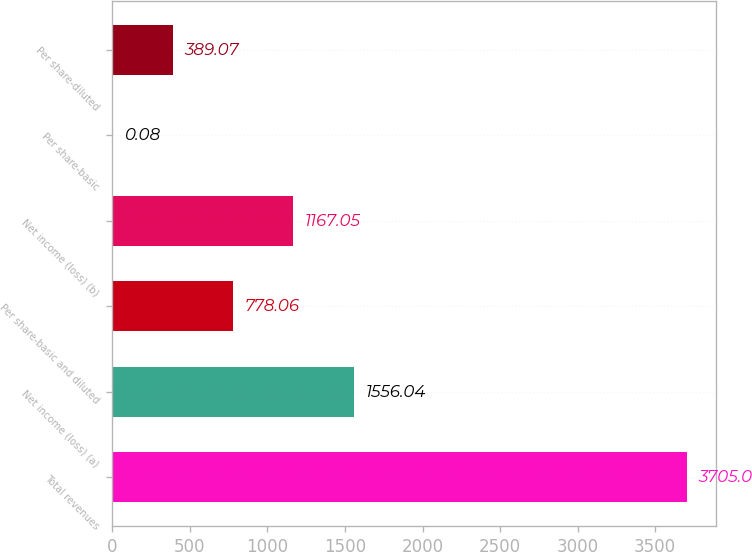Convert chart. <chart><loc_0><loc_0><loc_500><loc_500><bar_chart><fcel>Total revenues<fcel>Net income (loss) (a)<fcel>Per share-basic and diluted<fcel>Net income (loss) (b)<fcel>Per share-basic<fcel>Per share-diluted<nl><fcel>3705<fcel>1556.04<fcel>778.06<fcel>1167.05<fcel>0.08<fcel>389.07<nl></chart> 